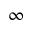Convert formula to latex. <formula><loc_0><loc_0><loc_500><loc_500>\infty</formula> 